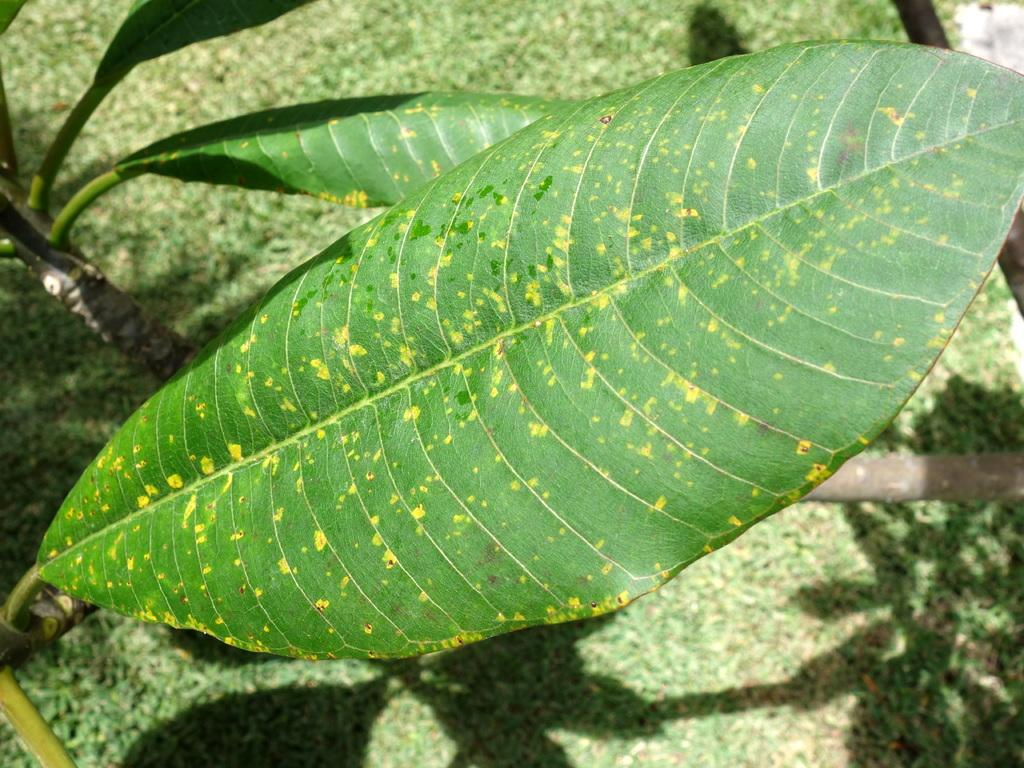What type of plant parts are visible in the image? The image contains leaves and stems of a tree. Can you describe the background of the image? The background of the image is blurred. What type of vegetable can be seen growing in the image? There is no vegetable present in the image; it features leaves and stems of a tree. Can you hear any thunder in the image? There is no sound present in the image, so it is not possible to determine if there is thunder. 